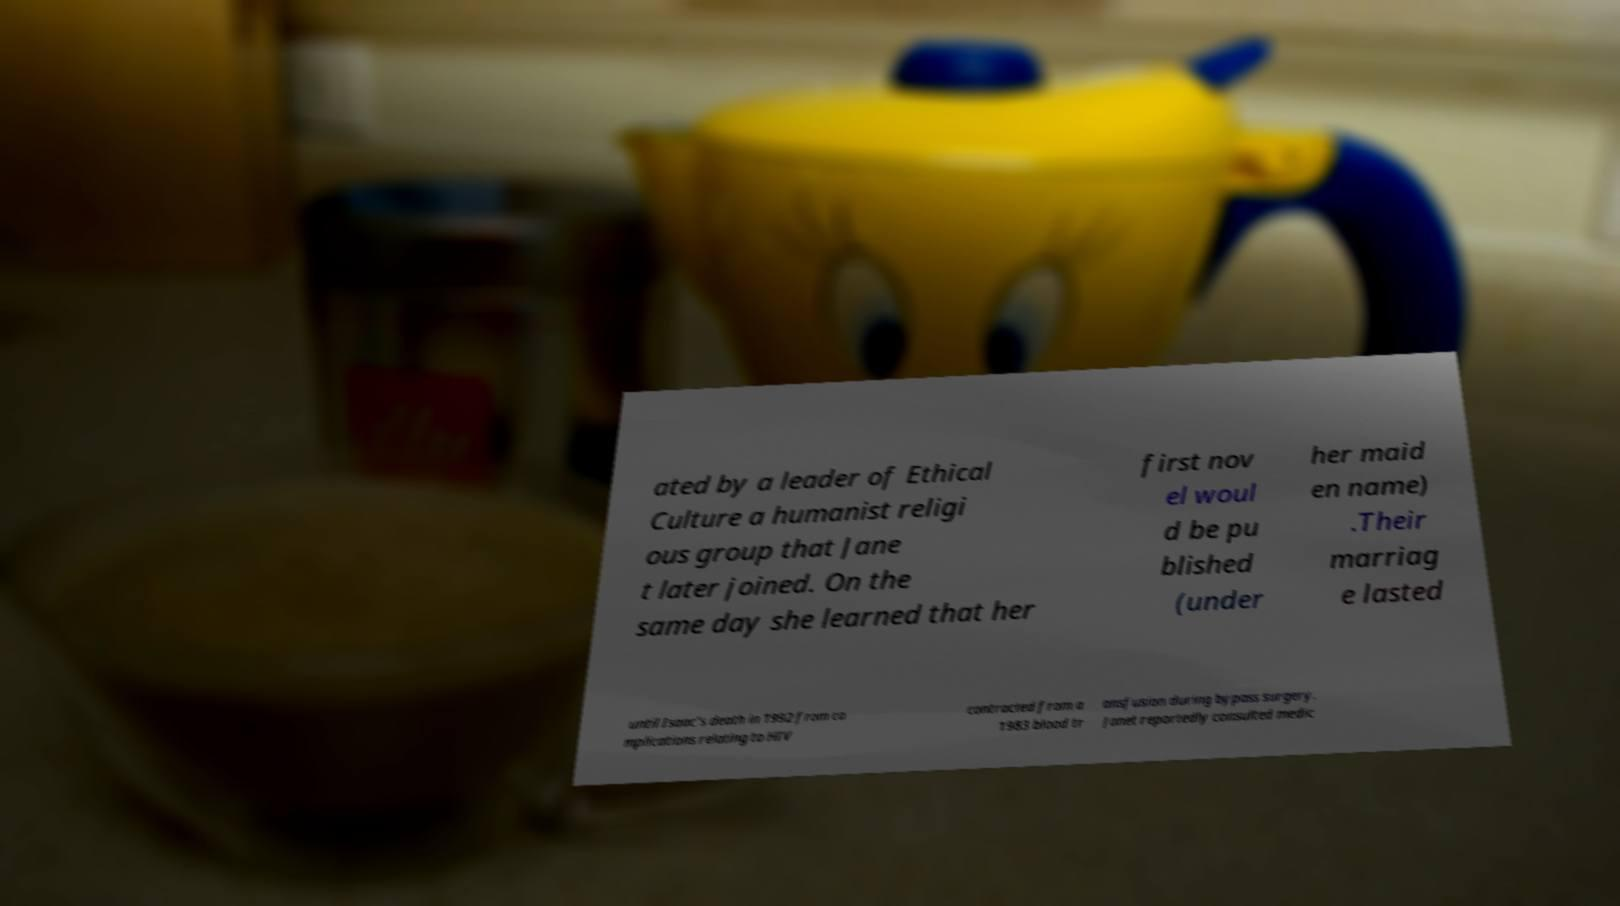Please read and relay the text visible in this image. What does it say? ated by a leader of Ethical Culture a humanist religi ous group that Jane t later joined. On the same day she learned that her first nov el woul d be pu blished (under her maid en name) .Their marriag e lasted until Isaac's death in 1992 from co mplications relating to HIV contracted from a 1983 blood tr ansfusion during bypass surgery. Janet reportedly consulted medic 